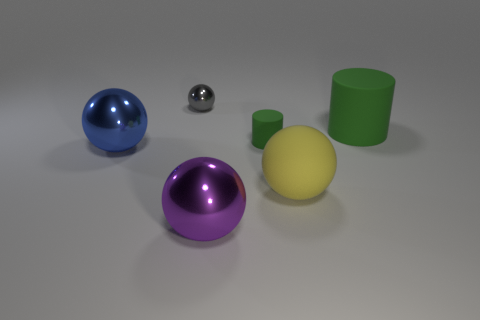Subtract all yellow rubber spheres. How many spheres are left? 3 Subtract all yellow spheres. How many spheres are left? 3 Subtract all spheres. How many objects are left? 2 Add 1 large yellow matte things. How many objects exist? 7 Subtract 0 green blocks. How many objects are left? 6 Subtract 1 cylinders. How many cylinders are left? 1 Subtract all blue cylinders. Subtract all purple blocks. How many cylinders are left? 2 Subtract all red cylinders. How many gray spheres are left? 1 Subtract all blue objects. Subtract all rubber spheres. How many objects are left? 4 Add 6 shiny things. How many shiny things are left? 9 